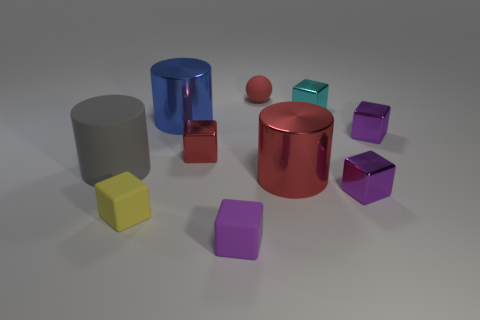Are there any small yellow cubes right of the tiny cyan cube?
Ensure brevity in your answer.  No. Do the yellow thing and the blue thing have the same size?
Offer a terse response. No. What number of small purple objects are the same material as the gray thing?
Offer a very short reply. 1. There is a shiny cylinder that is behind the big cylinder right of the red rubber object; how big is it?
Your response must be concise. Large. What color is the matte thing that is in front of the cyan block and behind the small yellow block?
Make the answer very short. Gray. Is the shape of the small yellow rubber object the same as the big red object?
Keep it short and to the point. No. The shiny cylinder that is the same color as the sphere is what size?
Ensure brevity in your answer.  Large. What is the shape of the purple metal object in front of the tiny red thing in front of the small red rubber sphere?
Give a very brief answer. Cube. Is the shape of the blue thing the same as the large gray matte object in front of the cyan block?
Give a very brief answer. Yes. There is a matte ball that is the same size as the cyan object; what is its color?
Your answer should be very brief. Red. 